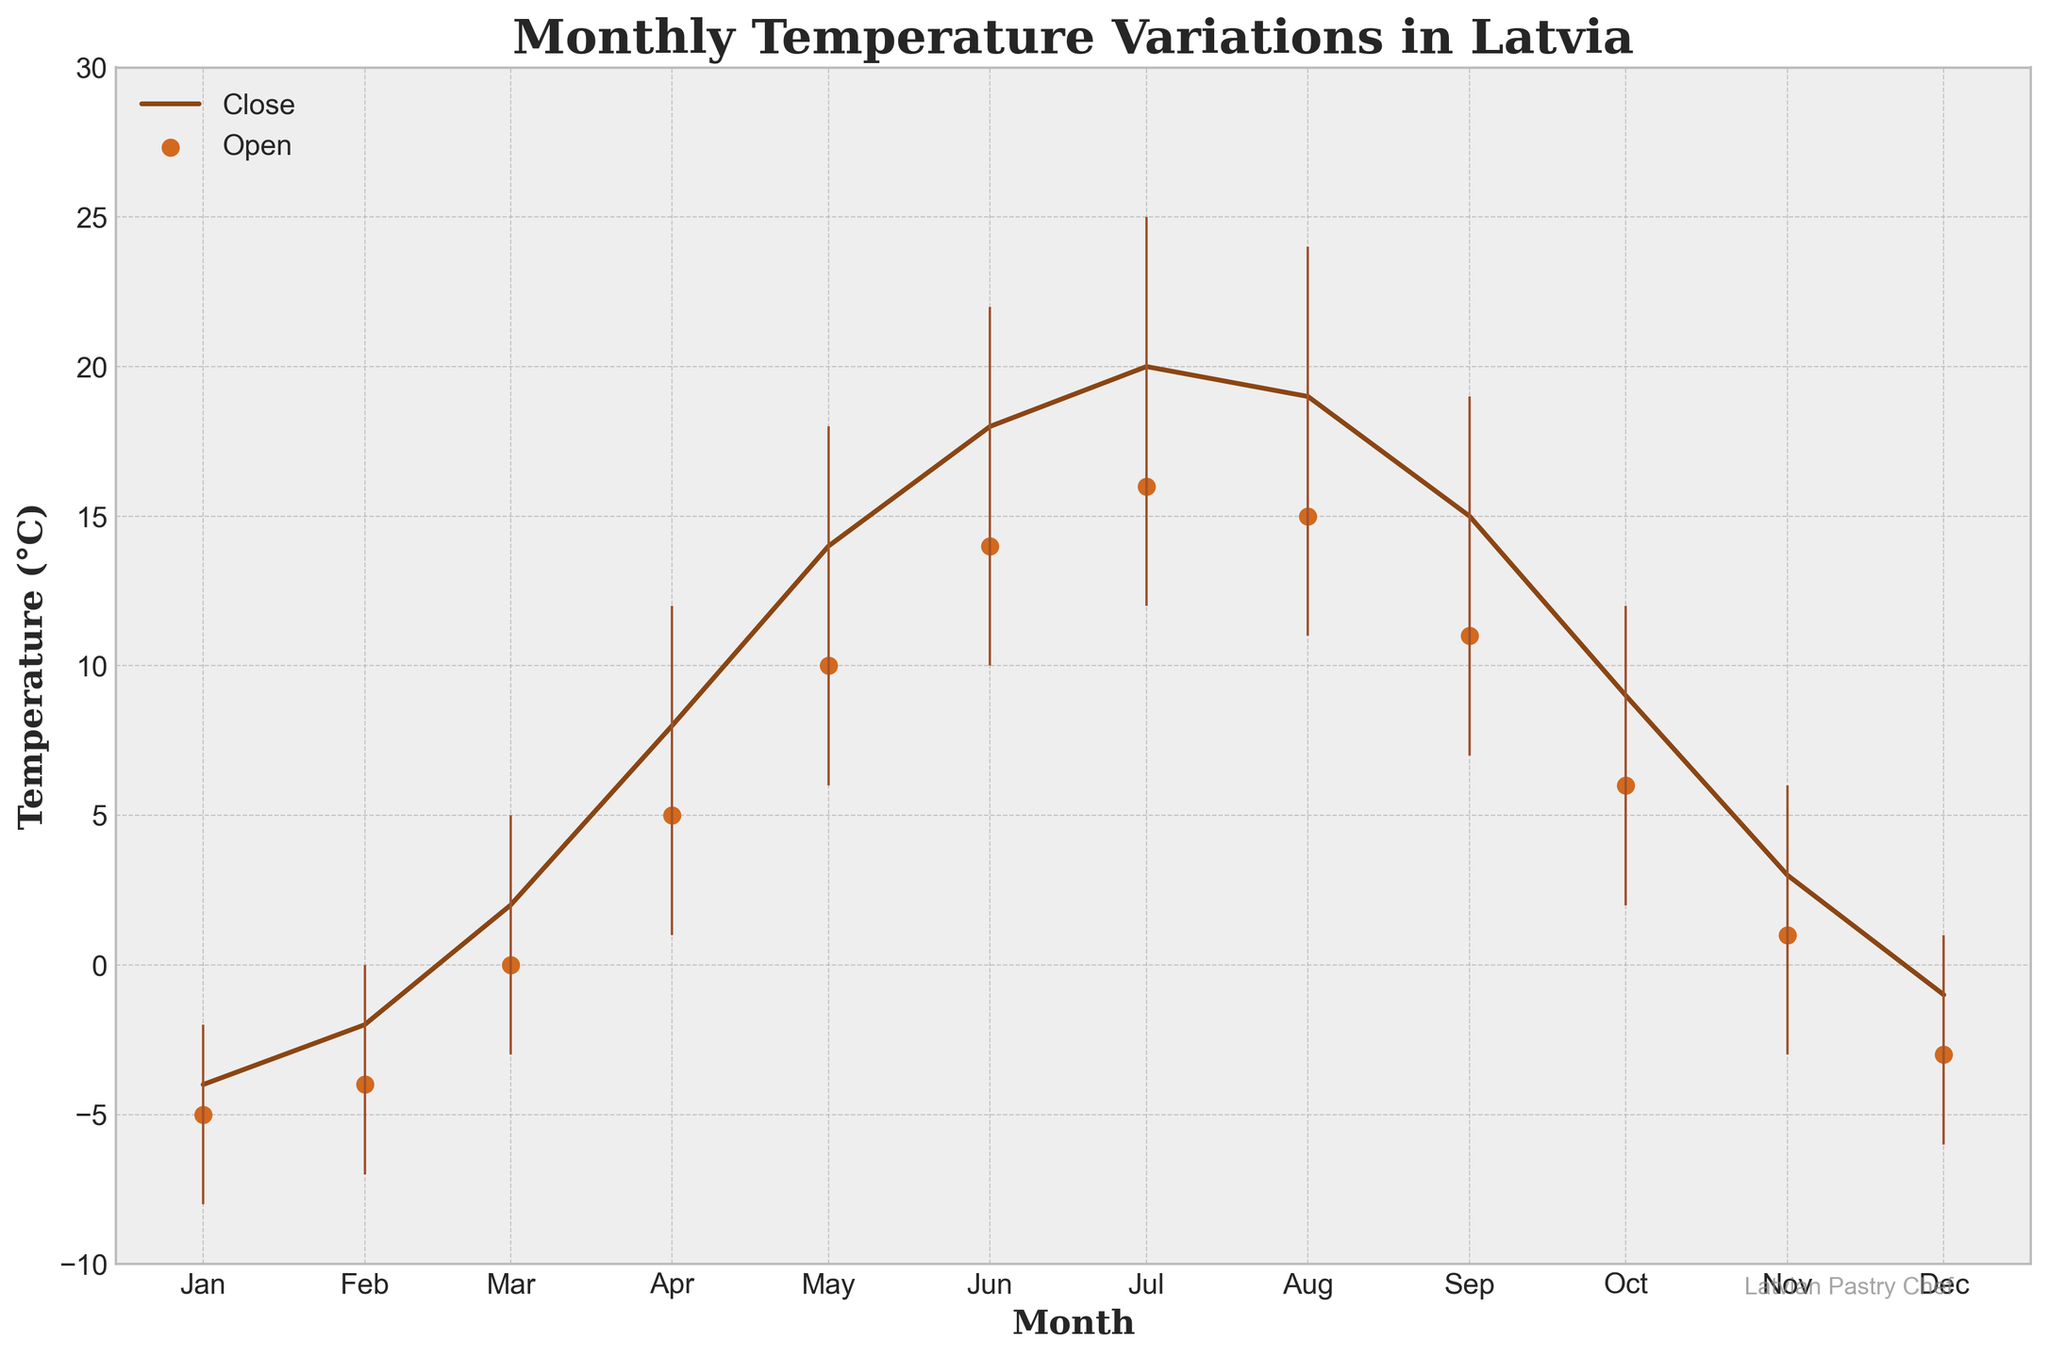What is the title of the figure? The title of the figure is shown at the top and gives an overview of what the chart represents.
Answer: Monthly Temperature Variations in Latvia What is the temperature range for February? The chart includes high and low temperatures marked with vertical lines for each month. For February, the high is 0°C and the low is -7°C.
Answer: 0°C to -7°C During which month is the closing temperature the highest? The closing temperature for each month is depicted by the position of the brown line. By observing the line, the highest closing temperature is for July.
Answer: July Which month has the largest temperature spread? The temperature spread is the difference between the highest and lowest temperatures. By comparing the vertical lines, May has the highest spread (18°C to 6°C = 12°C).
Answer: May What is the average opening temperature for January, February, and March? The opening temperatures for January, February, and March are -5°C, -4°C, and 0°C respectively. The average is calculated as (-5 + -4 + 0) / 3 = -3°C.
Answer: -3°C Which month has a lower closing temperature, November or December? The closing temperatures are represented by the positions of the brown line for November and December. November has a closing temperature of 3°C, while December has -1°C. December has the lower temperature.
Answer: December What is the difference between the high and low temperatures in July? The high and low temperatures for July are shown by the endpoints of the vertical lines. For July, high is 25°C and low is 12°C. The difference is 25 - 12 = 13°C.
Answer: 13°C Which month shows the highest increase in closing temperature from the previous month? By examining the brown line connecting closing temperatures, the biggest jump happens between March (2°C) and April (8°C). The increase is 8°C - 2°C = 6°C.
Answer: April How much does the closing temperature in June differ from the opening temperature in July? The closing temperature in June is 18°C and the opening temperature in July is 16°C. The difference is 18 - 16 = 2°C.
Answer: 2°C What is the general trend in temperature from January to December? Observing the overall pattern of the brown line indicating closing temperatures, we can see a general increase reaching a peak in July, followed by a decrease towards December.
Answer: Increase then decrease 